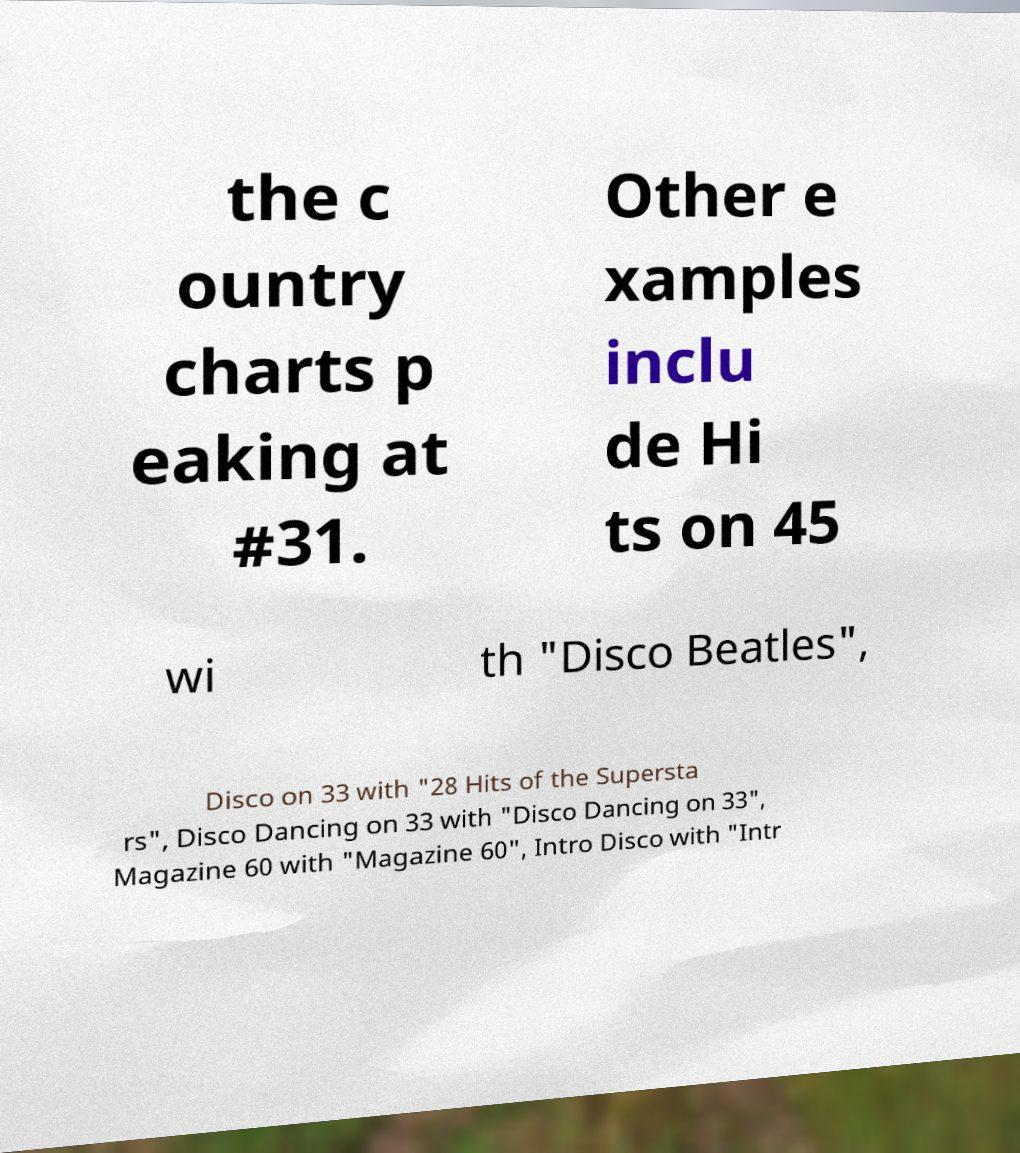Can you accurately transcribe the text from the provided image for me? the c ountry charts p eaking at #31. Other e xamples inclu de Hi ts on 45 wi th "Disco Beatles", Disco on 33 with "28 Hits of the Supersta rs", Disco Dancing on 33 with "Disco Dancing on 33", Magazine 60 with "Magazine 60", Intro Disco with "Intr 